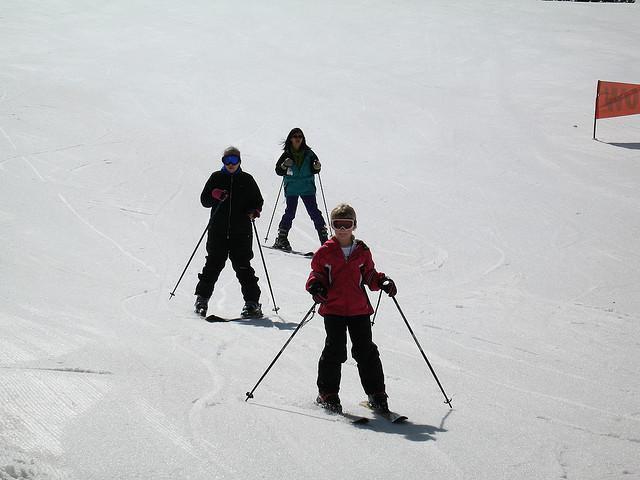How many people are shown?
Give a very brief answer. 3. How many people in this photo are skiing?
Give a very brief answer. 3. How many people are on the slope?
Give a very brief answer. 3. How many skiers?
Give a very brief answer. 3. How many people are skiing?
Give a very brief answer. 3. How many people in the picture?
Give a very brief answer. 3. How many people are in the photo?
Give a very brief answer. 3. 